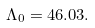Convert formula to latex. <formula><loc_0><loc_0><loc_500><loc_500>\Lambda _ { 0 } = 4 6 . 0 3 .</formula> 